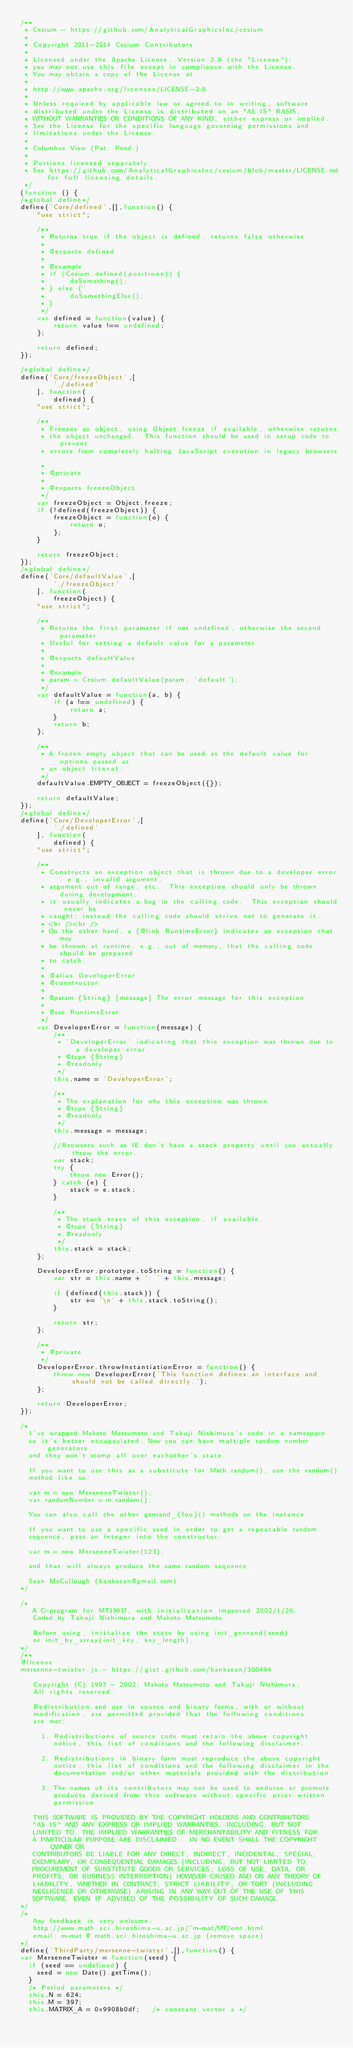Convert code to text. <code><loc_0><loc_0><loc_500><loc_500><_JavaScript_>/**
 * Cesium - https://github.com/AnalyticalGraphicsInc/cesium
 *
 * Copyright 2011-2014 Cesium Contributors
 *
 * Licensed under the Apache License, Version 2.0 (the "License");
 * you may not use this file except in compliance with the License.
 * You may obtain a copy of the License at
 *
 * http://www.apache.org/licenses/LICENSE-2.0
 *
 * Unless required by applicable law or agreed to in writing, software
 * distributed under the License is distributed on an "AS IS" BASIS,
 * WITHOUT WARRANTIES OR CONDITIONS OF ANY KIND, either express or implied.
 * See the License for the specific language governing permissions and
 * limitations under the License.
 *
 * Columbus View (Pat. Pend.)
 *
 * Portions licensed separately.
 * See https://github.com/AnalyticalGraphicsInc/cesium/blob/master/LICENSE.md for full licensing details.
 */
(function () {
/*global define*/
define('Core/defined',[],function() {
    "use strict";

    /**
     * Returns true if the object is defined, returns false otherwise.
     *
     * @exports defined
     *
     * @example
     * if (Cesium.defined(positions)) {
     *      doSomething();
     * } else {
     *      doSomethingElse();
     * }
     */
    var defined = function(value) {
        return value !== undefined;
    };

    return defined;
});

/*global define*/
define('Core/freezeObject',[
        './defined'
    ], function(
        defined) {
    "use strict";

    /**
     * Freezes an object, using Object.freeze if available, otherwise returns
     * the object unchanged.  This function should be used in setup code to prevent
     * errors from completely halting JavaScript execution in legacy browsers.
     *
     * @private
     *
     * @exports freezeObject
     */
    var freezeObject = Object.freeze;
    if (!defined(freezeObject)) {
        freezeObject = function(o) {
            return o;
        };
    }

    return freezeObject;
});
/*global define*/
define('Core/defaultValue',[
        './freezeObject'
    ], function(
        freezeObject) {
    "use strict";

    /**
     * Returns the first parameter if not undefined, otherwise the second parameter.
     * Useful for setting a default value for a parameter.
     *
     * @exports defaultValue
     *
     * @example
     * param = Cesium.defaultValue(param, 'default');
     */
    var defaultValue = function(a, b) {
        if (a !== undefined) {
            return a;
        }
        return b;
    };

    /**
     * A frozen empty object that can be used as the default value for options passed as
     * an object literal.
     */
    defaultValue.EMPTY_OBJECT = freezeObject({});

    return defaultValue;
});
/*global define*/
define('Core/DeveloperError',[
        './defined'
    ], function(
        defined) {
    "use strict";

    /**
     * Constructs an exception object that is thrown due to a developer error, e.g., invalid argument,
     * argument out of range, etc.  This exception should only be thrown during development;
     * it usually indicates a bug in the calling code.  This exception should never be
     * caught; instead the calling code should strive not to generate it.
     * <br /><br />
     * On the other hand, a {@link RuntimeError} indicates an exception that may
     * be thrown at runtime, e.g., out of memory, that the calling code should be prepared
     * to catch.
     *
     * @alias DeveloperError
     * @constructor
     *
     * @param {String} [message] The error message for this exception.
     *
     * @see RuntimeError
     */
    var DeveloperError = function(message) {
        /**
         * 'DeveloperError' indicating that this exception was thrown due to a developer error.
         * @type {String}
         * @readonly
         */
        this.name = 'DeveloperError';

        /**
         * The explanation for why this exception was thrown.
         * @type {String}
         * @readonly
         */
        this.message = message;

        //Browsers such as IE don't have a stack property until you actually throw the error.
        var stack;
        try {
            throw new Error();
        } catch (e) {
            stack = e.stack;
        }

        /**
         * The stack trace of this exception, if available.
         * @type {String}
         * @readonly
         */
        this.stack = stack;
    };

    DeveloperError.prototype.toString = function() {
        var str = this.name + ': ' + this.message;

        if (defined(this.stack)) {
            str += '\n' + this.stack.toString();
        }

        return str;
    };

    /**
     * @private
     */
    DeveloperError.throwInstantiationError = function() {
        throw new DeveloperError('This function defines an interface and should not be called directly.');
    };

    return DeveloperError;
});

/*
  I've wrapped Makoto Matsumoto and Takuji Nishimura's code in a namespace
  so it's better encapsulated. Now you can have multiple random number generators
  and they won't stomp all over eachother's state.

  If you want to use this as a substitute for Math.random(), use the random()
  method like so:

  var m = new MersenneTwister();
  var randomNumber = m.random();

  You can also call the other genrand_{foo}() methods on the instance.

  If you want to use a specific seed in order to get a repeatable random
  sequence, pass an integer into the constructor:

  var m = new MersenneTwister(123);

  and that will always produce the same random sequence.

  Sean McCullough (banksean@gmail.com)
*/

/*
   A C-program for MT19937, with initialization improved 2002/1/26.
   Coded by Takuji Nishimura and Makoto Matsumoto.

   Before using, initialize the state by using init_genrand(seed)
   or init_by_array(init_key, key_length).
*/
/**
@license
mersenne-twister.js - https://gist.github.com/banksean/300494

   Copyright (C) 1997 - 2002, Makoto Matsumoto and Takuji Nishimura,
   All rights reserved.

   Redistribution and use in source and binary forms, with or without
   modification, are permitted provided that the following conditions
   are met:

     1. Redistributions of source code must retain the above copyright
        notice, this list of conditions and the following disclaimer.

     2. Redistributions in binary form must reproduce the above copyright
        notice, this list of conditions and the following disclaimer in the
        documentation and/or other materials provided with the distribution.

     3. The names of its contributors may not be used to endorse or promote
        products derived from this software without specific prior written
        permission.

   THIS SOFTWARE IS PROVIDED BY THE COPYRIGHT HOLDERS AND CONTRIBUTORS
   "AS IS" AND ANY EXPRESS OR IMPLIED WARRANTIES, INCLUDING, BUT NOT
   LIMITED TO, THE IMPLIED WARRANTIES OF MERCHANTABILITY AND FITNESS FOR
   A PARTICULAR PURPOSE ARE DISCLAIMED.  IN NO EVENT SHALL THE COPYRIGHT OWNER OR
   CONTRIBUTORS BE LIABLE FOR ANY DIRECT, INDIRECT, INCIDENTAL, SPECIAL,
   EXEMPLARY, OR CONSEQUENTIAL DAMAGES (INCLUDING, BUT NOT LIMITED TO,
   PROCUREMENT OF SUBSTITUTE GOODS OR SERVICES; LOSS OF USE, DATA, OR
   PROFITS; OR BUSINESS INTERRUPTION) HOWEVER CAUSED AND ON ANY THEORY OF
   LIABILITY, WHETHER IN CONTRACT, STRICT LIABILITY, OR TORT (INCLUDING
   NEGLIGENCE OR OTHERWISE) ARISING IN ANY WAY OUT OF THE USE OF THIS
   SOFTWARE, EVEN IF ADVISED OF THE POSSIBILITY OF SUCH DAMAGE.
*/
/*
   Any feedback is very welcome.
   http://www.math.sci.hiroshima-u.ac.jp/~m-mat/MT/emt.html
   email: m-mat @ math.sci.hiroshima-u.ac.jp (remove space)
*/
define('ThirdParty/mersenne-twister',[],function() {
var MersenneTwister = function(seed) {
  if (seed == undefined) {
    seed = new Date().getTime();
  }
  /* Period parameters */
  this.N = 624;
  this.M = 397;
  this.MATRIX_A = 0x9908b0df;   /* constant vector a */</code> 